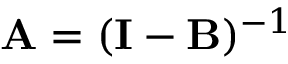<formula> <loc_0><loc_0><loc_500><loc_500>A = ( I - B ) ^ { - 1 }</formula> 